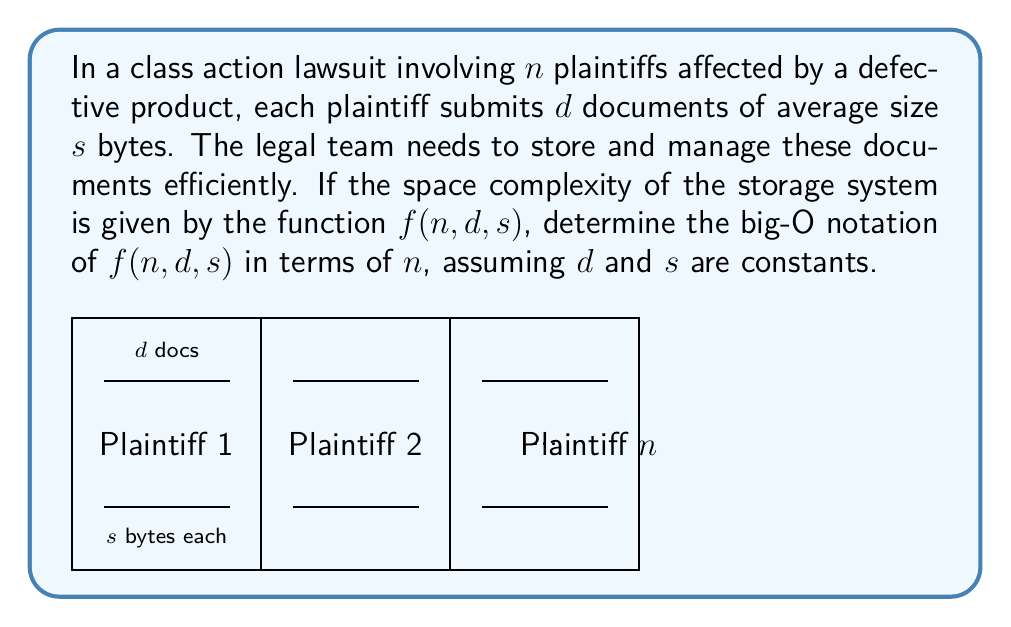Show me your answer to this math problem. To determine the space complexity, let's follow these steps:

1) For each plaintiff, we store $d$ documents, each of size $s$ bytes.

2) The total storage for one plaintiff is $d \cdot s$ bytes.

3) There are $n$ plaintiffs, so the total storage needed is:

   $f(n, d, s) = n \cdot d \cdot s$ bytes

4) We're told that $d$ and $s$ are constants. In big-O notation, we can treat constants as 1. So our function simplifies to:

   $f(n) = n \cdot 1 \cdot 1 = n$

5) Therefore, the space complexity in big-O notation is $O(n)$.

This means that the space required grows linearly with the number of plaintiffs, which makes sense intuitively: twice as many plaintiffs would require twice as much storage space.
Answer: $O(n)$ 